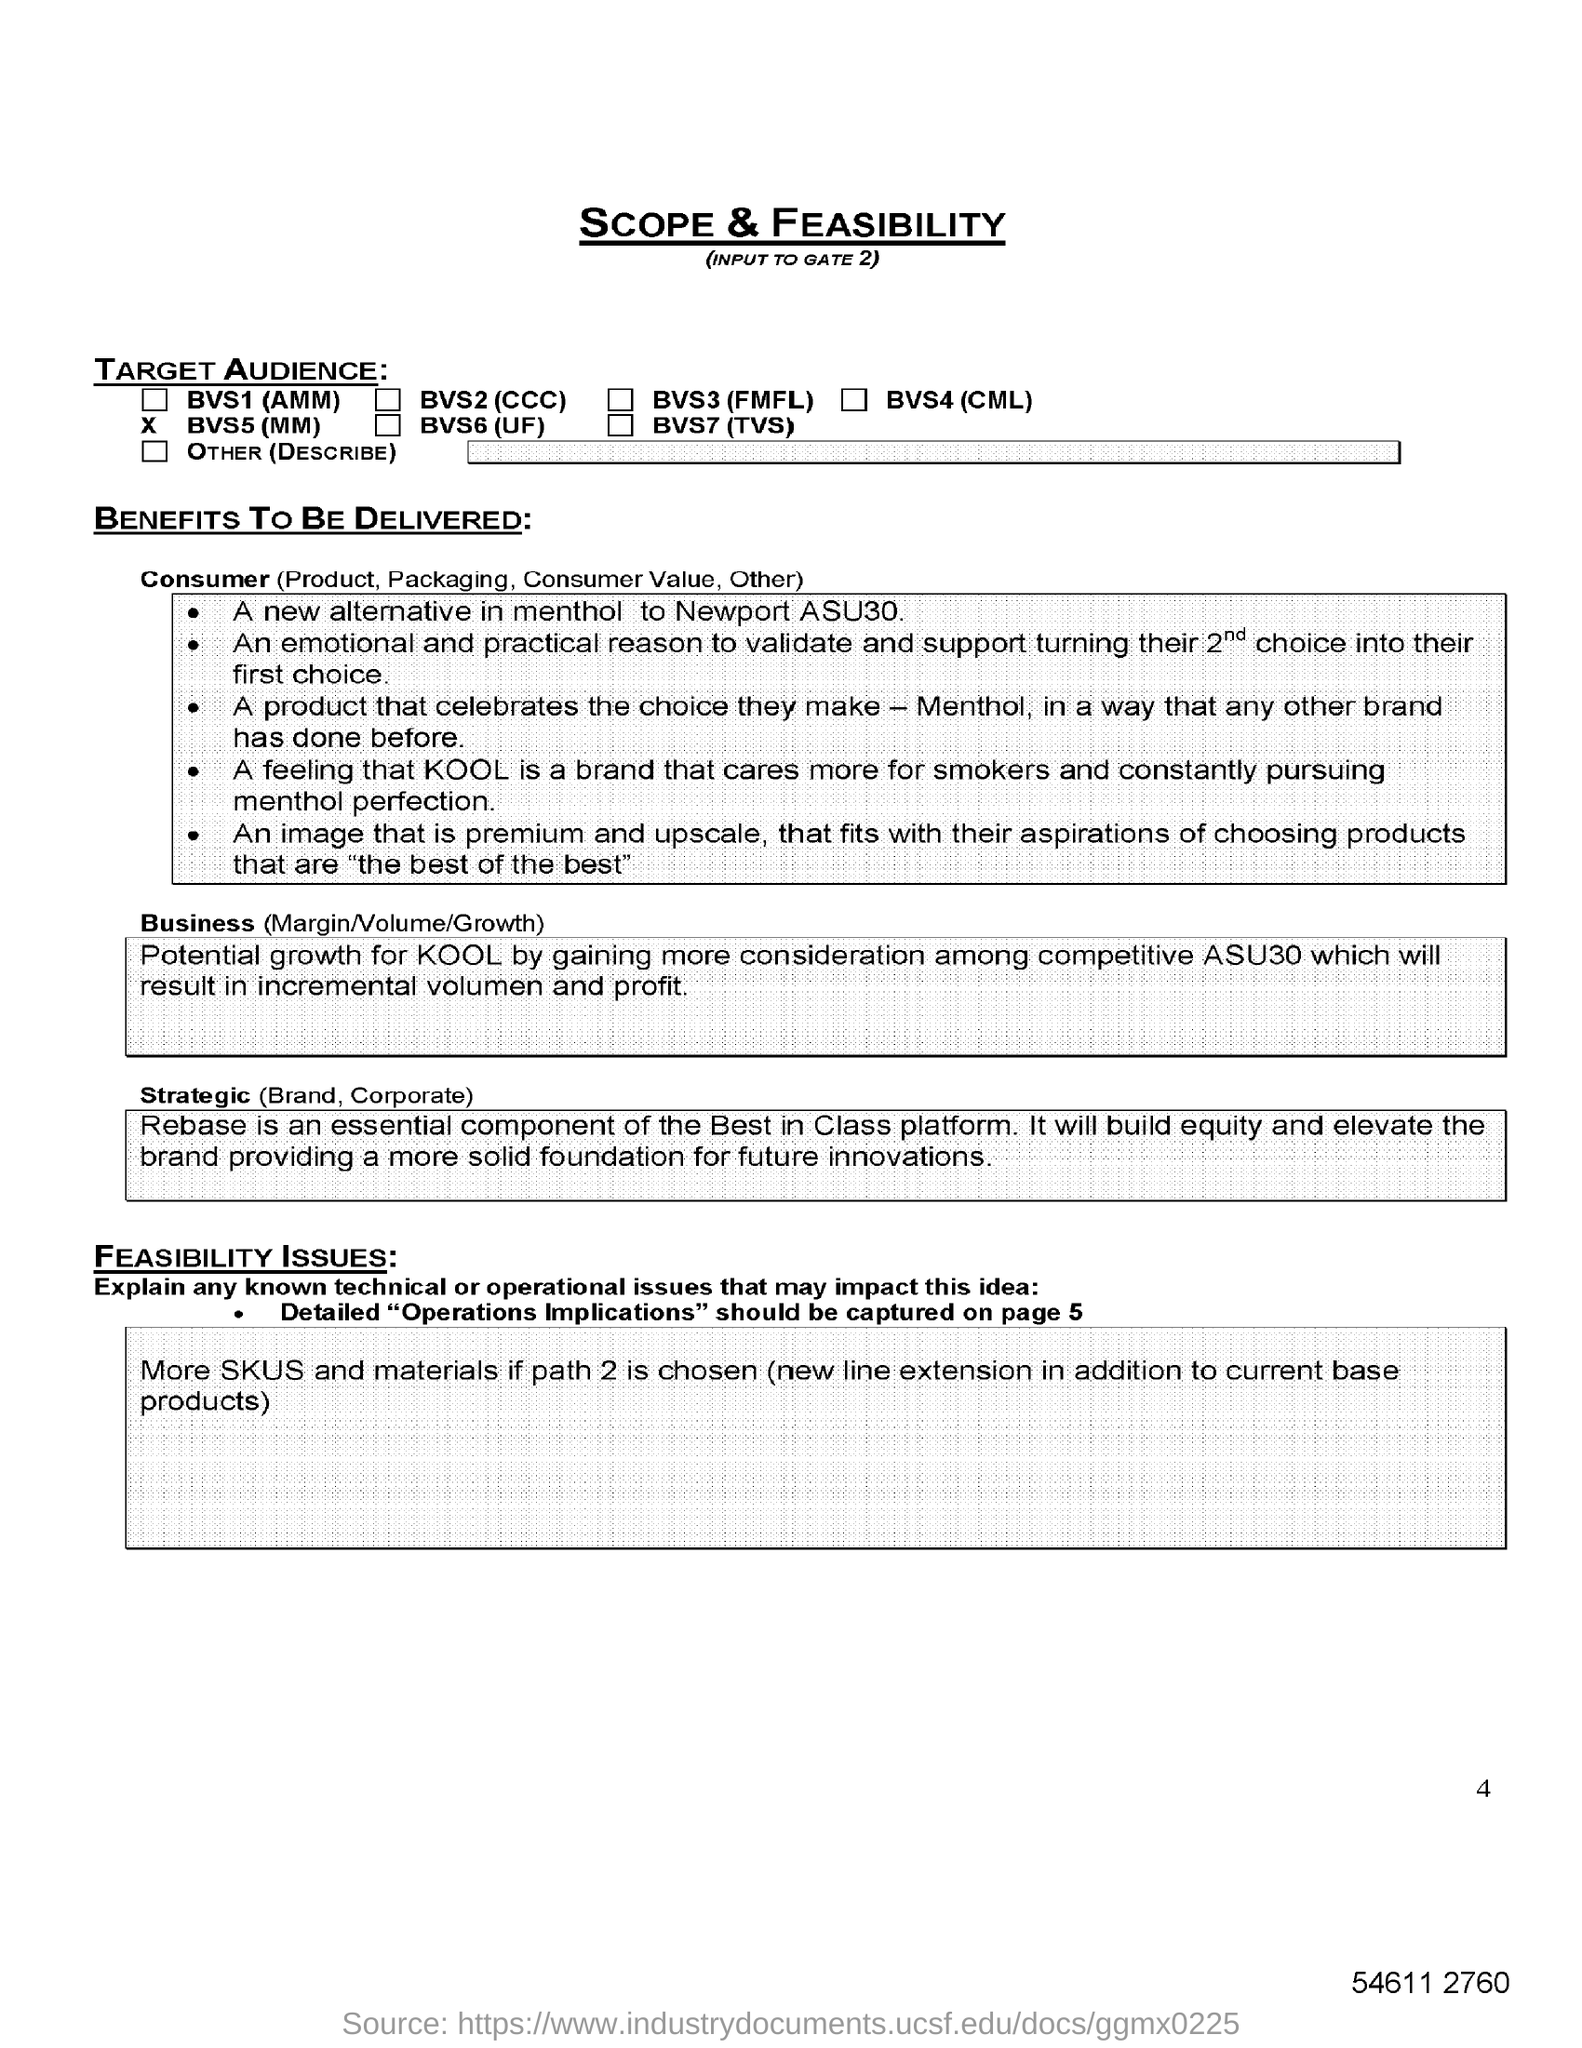Identify some key points in this picture. KOOL, the brand that prioritizes the well-being of its consumers, particularly smokers, who are constantly seeking the perfect blend of menthol flavor. The alternative to menthol in the product "Newport ASU30" is unknown. The document's heading is 'SCOPE & FEASIBILITY.' The first target audience mentioned is BVS1 (AMM). 